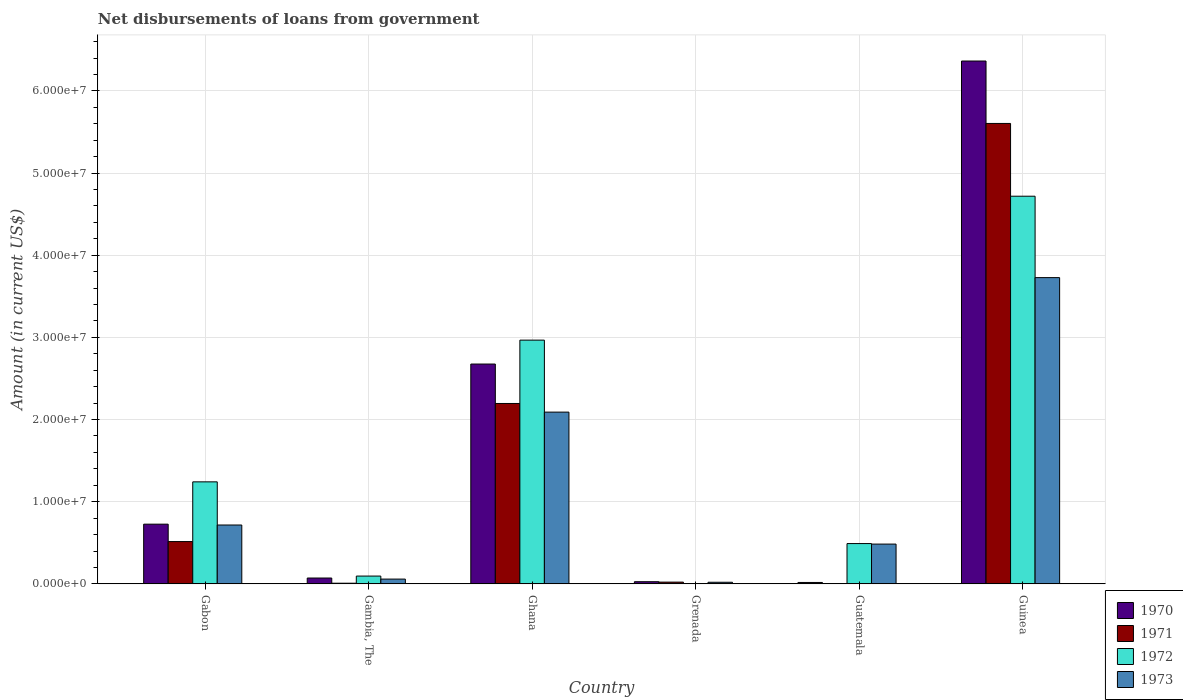Are the number of bars per tick equal to the number of legend labels?
Make the answer very short. No. How many bars are there on the 1st tick from the left?
Provide a succinct answer. 4. What is the label of the 5th group of bars from the left?
Offer a terse response. Guatemala. In how many cases, is the number of bars for a given country not equal to the number of legend labels?
Make the answer very short. 2. What is the amount of loan disbursed from government in 1970 in Ghana?
Give a very brief answer. 2.68e+07. Across all countries, what is the maximum amount of loan disbursed from government in 1970?
Your answer should be very brief. 6.36e+07. Across all countries, what is the minimum amount of loan disbursed from government in 1970?
Your response must be concise. 1.70e+05. In which country was the amount of loan disbursed from government in 1970 maximum?
Keep it short and to the point. Guinea. What is the total amount of loan disbursed from government in 1973 in the graph?
Keep it short and to the point. 7.10e+07. What is the difference between the amount of loan disbursed from government in 1973 in Gabon and that in Gambia, The?
Your answer should be compact. 6.58e+06. What is the difference between the amount of loan disbursed from government in 1971 in Gabon and the amount of loan disbursed from government in 1973 in Guatemala?
Keep it short and to the point. 3.07e+05. What is the average amount of loan disbursed from government in 1971 per country?
Offer a terse response. 1.39e+07. What is the difference between the amount of loan disbursed from government of/in 1972 and amount of loan disbursed from government of/in 1973 in Gabon?
Your answer should be compact. 5.25e+06. In how many countries, is the amount of loan disbursed from government in 1970 greater than 44000000 US$?
Your answer should be very brief. 1. What is the ratio of the amount of loan disbursed from government in 1973 in Gabon to that in Grenada?
Keep it short and to the point. 36.74. Is the amount of loan disbursed from government in 1971 in Gambia, The less than that in Grenada?
Give a very brief answer. Yes. Is the difference between the amount of loan disbursed from government in 1972 in Guatemala and Guinea greater than the difference between the amount of loan disbursed from government in 1973 in Guatemala and Guinea?
Give a very brief answer. No. What is the difference between the highest and the second highest amount of loan disbursed from government in 1970?
Keep it short and to the point. 3.69e+07. What is the difference between the highest and the lowest amount of loan disbursed from government in 1971?
Ensure brevity in your answer.  5.60e+07. In how many countries, is the amount of loan disbursed from government in 1973 greater than the average amount of loan disbursed from government in 1973 taken over all countries?
Provide a short and direct response. 2. Is the sum of the amount of loan disbursed from government in 1970 in Grenada and Guinea greater than the maximum amount of loan disbursed from government in 1972 across all countries?
Provide a succinct answer. Yes. Is it the case that in every country, the sum of the amount of loan disbursed from government in 1973 and amount of loan disbursed from government in 1972 is greater than the sum of amount of loan disbursed from government in 1971 and amount of loan disbursed from government in 1970?
Give a very brief answer. No. Is it the case that in every country, the sum of the amount of loan disbursed from government in 1973 and amount of loan disbursed from government in 1970 is greater than the amount of loan disbursed from government in 1972?
Provide a succinct answer. Yes. How many bars are there?
Your response must be concise. 22. Are all the bars in the graph horizontal?
Offer a terse response. No. Where does the legend appear in the graph?
Your answer should be very brief. Bottom right. How are the legend labels stacked?
Ensure brevity in your answer.  Vertical. What is the title of the graph?
Offer a terse response. Net disbursements of loans from government. What is the Amount (in current US$) of 1970 in Gabon?
Your answer should be compact. 7.27e+06. What is the Amount (in current US$) of 1971 in Gabon?
Your answer should be compact. 5.15e+06. What is the Amount (in current US$) in 1972 in Gabon?
Offer a very short reply. 1.24e+07. What is the Amount (in current US$) of 1973 in Gabon?
Ensure brevity in your answer.  7.16e+06. What is the Amount (in current US$) of 1970 in Gambia, The?
Offer a terse response. 7.11e+05. What is the Amount (in current US$) of 1971 in Gambia, The?
Offer a terse response. 8.00e+04. What is the Amount (in current US$) in 1972 in Gambia, The?
Give a very brief answer. 9.48e+05. What is the Amount (in current US$) of 1973 in Gambia, The?
Ensure brevity in your answer.  5.81e+05. What is the Amount (in current US$) of 1970 in Ghana?
Make the answer very short. 2.68e+07. What is the Amount (in current US$) in 1971 in Ghana?
Provide a short and direct response. 2.20e+07. What is the Amount (in current US$) in 1972 in Ghana?
Provide a succinct answer. 2.97e+07. What is the Amount (in current US$) in 1973 in Ghana?
Your answer should be very brief. 2.09e+07. What is the Amount (in current US$) of 1970 in Grenada?
Make the answer very short. 2.62e+05. What is the Amount (in current US$) in 1971 in Grenada?
Your response must be concise. 2.13e+05. What is the Amount (in current US$) in 1972 in Grenada?
Offer a terse response. 0. What is the Amount (in current US$) of 1973 in Grenada?
Your answer should be compact. 1.95e+05. What is the Amount (in current US$) of 1972 in Guatemala?
Offer a terse response. 4.90e+06. What is the Amount (in current US$) in 1973 in Guatemala?
Your answer should be compact. 4.84e+06. What is the Amount (in current US$) of 1970 in Guinea?
Your answer should be very brief. 6.36e+07. What is the Amount (in current US$) of 1971 in Guinea?
Give a very brief answer. 5.60e+07. What is the Amount (in current US$) in 1972 in Guinea?
Give a very brief answer. 4.72e+07. What is the Amount (in current US$) of 1973 in Guinea?
Your response must be concise. 3.73e+07. Across all countries, what is the maximum Amount (in current US$) in 1970?
Your answer should be compact. 6.36e+07. Across all countries, what is the maximum Amount (in current US$) in 1971?
Make the answer very short. 5.60e+07. Across all countries, what is the maximum Amount (in current US$) of 1972?
Your response must be concise. 4.72e+07. Across all countries, what is the maximum Amount (in current US$) in 1973?
Keep it short and to the point. 3.73e+07. Across all countries, what is the minimum Amount (in current US$) of 1971?
Make the answer very short. 0. Across all countries, what is the minimum Amount (in current US$) in 1972?
Keep it short and to the point. 0. Across all countries, what is the minimum Amount (in current US$) of 1973?
Keep it short and to the point. 1.95e+05. What is the total Amount (in current US$) in 1970 in the graph?
Ensure brevity in your answer.  9.88e+07. What is the total Amount (in current US$) in 1971 in the graph?
Provide a succinct answer. 8.34e+07. What is the total Amount (in current US$) of 1972 in the graph?
Keep it short and to the point. 9.51e+07. What is the total Amount (in current US$) in 1973 in the graph?
Your response must be concise. 7.10e+07. What is the difference between the Amount (in current US$) in 1970 in Gabon and that in Gambia, The?
Your answer should be compact. 6.56e+06. What is the difference between the Amount (in current US$) in 1971 in Gabon and that in Gambia, The?
Give a very brief answer. 5.07e+06. What is the difference between the Amount (in current US$) in 1972 in Gabon and that in Gambia, The?
Ensure brevity in your answer.  1.15e+07. What is the difference between the Amount (in current US$) in 1973 in Gabon and that in Gambia, The?
Offer a terse response. 6.58e+06. What is the difference between the Amount (in current US$) of 1970 in Gabon and that in Ghana?
Offer a very short reply. -1.95e+07. What is the difference between the Amount (in current US$) in 1971 in Gabon and that in Ghana?
Make the answer very short. -1.68e+07. What is the difference between the Amount (in current US$) in 1972 in Gabon and that in Ghana?
Give a very brief answer. -1.73e+07. What is the difference between the Amount (in current US$) in 1973 in Gabon and that in Ghana?
Offer a terse response. -1.37e+07. What is the difference between the Amount (in current US$) in 1970 in Gabon and that in Grenada?
Offer a very short reply. 7.01e+06. What is the difference between the Amount (in current US$) of 1971 in Gabon and that in Grenada?
Make the answer very short. 4.94e+06. What is the difference between the Amount (in current US$) of 1973 in Gabon and that in Grenada?
Provide a short and direct response. 6.97e+06. What is the difference between the Amount (in current US$) in 1970 in Gabon and that in Guatemala?
Give a very brief answer. 7.10e+06. What is the difference between the Amount (in current US$) of 1972 in Gabon and that in Guatemala?
Offer a very short reply. 7.51e+06. What is the difference between the Amount (in current US$) in 1973 in Gabon and that in Guatemala?
Your answer should be compact. 2.32e+06. What is the difference between the Amount (in current US$) in 1970 in Gabon and that in Guinea?
Offer a terse response. -5.64e+07. What is the difference between the Amount (in current US$) of 1971 in Gabon and that in Guinea?
Keep it short and to the point. -5.09e+07. What is the difference between the Amount (in current US$) of 1972 in Gabon and that in Guinea?
Give a very brief answer. -3.48e+07. What is the difference between the Amount (in current US$) in 1973 in Gabon and that in Guinea?
Your answer should be compact. -3.01e+07. What is the difference between the Amount (in current US$) in 1970 in Gambia, The and that in Ghana?
Ensure brevity in your answer.  -2.60e+07. What is the difference between the Amount (in current US$) of 1971 in Gambia, The and that in Ghana?
Your answer should be very brief. -2.19e+07. What is the difference between the Amount (in current US$) in 1972 in Gambia, The and that in Ghana?
Give a very brief answer. -2.87e+07. What is the difference between the Amount (in current US$) in 1973 in Gambia, The and that in Ghana?
Give a very brief answer. -2.03e+07. What is the difference between the Amount (in current US$) in 1970 in Gambia, The and that in Grenada?
Make the answer very short. 4.49e+05. What is the difference between the Amount (in current US$) in 1971 in Gambia, The and that in Grenada?
Provide a short and direct response. -1.33e+05. What is the difference between the Amount (in current US$) of 1973 in Gambia, The and that in Grenada?
Keep it short and to the point. 3.86e+05. What is the difference between the Amount (in current US$) in 1970 in Gambia, The and that in Guatemala?
Your answer should be compact. 5.41e+05. What is the difference between the Amount (in current US$) in 1972 in Gambia, The and that in Guatemala?
Provide a succinct answer. -3.96e+06. What is the difference between the Amount (in current US$) in 1973 in Gambia, The and that in Guatemala?
Your response must be concise. -4.26e+06. What is the difference between the Amount (in current US$) in 1970 in Gambia, The and that in Guinea?
Your answer should be compact. -6.29e+07. What is the difference between the Amount (in current US$) in 1971 in Gambia, The and that in Guinea?
Offer a terse response. -5.60e+07. What is the difference between the Amount (in current US$) of 1972 in Gambia, The and that in Guinea?
Provide a short and direct response. -4.62e+07. What is the difference between the Amount (in current US$) in 1973 in Gambia, The and that in Guinea?
Your response must be concise. -3.67e+07. What is the difference between the Amount (in current US$) in 1970 in Ghana and that in Grenada?
Offer a terse response. 2.65e+07. What is the difference between the Amount (in current US$) of 1971 in Ghana and that in Grenada?
Your answer should be compact. 2.17e+07. What is the difference between the Amount (in current US$) of 1973 in Ghana and that in Grenada?
Offer a very short reply. 2.07e+07. What is the difference between the Amount (in current US$) of 1970 in Ghana and that in Guatemala?
Provide a short and direct response. 2.66e+07. What is the difference between the Amount (in current US$) of 1972 in Ghana and that in Guatemala?
Offer a terse response. 2.48e+07. What is the difference between the Amount (in current US$) in 1973 in Ghana and that in Guatemala?
Offer a very short reply. 1.61e+07. What is the difference between the Amount (in current US$) of 1970 in Ghana and that in Guinea?
Provide a short and direct response. -3.69e+07. What is the difference between the Amount (in current US$) in 1971 in Ghana and that in Guinea?
Provide a short and direct response. -3.41e+07. What is the difference between the Amount (in current US$) of 1972 in Ghana and that in Guinea?
Keep it short and to the point. -1.75e+07. What is the difference between the Amount (in current US$) in 1973 in Ghana and that in Guinea?
Offer a very short reply. -1.64e+07. What is the difference between the Amount (in current US$) of 1970 in Grenada and that in Guatemala?
Give a very brief answer. 9.20e+04. What is the difference between the Amount (in current US$) in 1973 in Grenada and that in Guatemala?
Provide a succinct answer. -4.65e+06. What is the difference between the Amount (in current US$) of 1970 in Grenada and that in Guinea?
Keep it short and to the point. -6.34e+07. What is the difference between the Amount (in current US$) of 1971 in Grenada and that in Guinea?
Provide a short and direct response. -5.58e+07. What is the difference between the Amount (in current US$) of 1973 in Grenada and that in Guinea?
Ensure brevity in your answer.  -3.71e+07. What is the difference between the Amount (in current US$) in 1970 in Guatemala and that in Guinea?
Your answer should be compact. -6.35e+07. What is the difference between the Amount (in current US$) of 1972 in Guatemala and that in Guinea?
Ensure brevity in your answer.  -4.23e+07. What is the difference between the Amount (in current US$) of 1973 in Guatemala and that in Guinea?
Your answer should be compact. -3.24e+07. What is the difference between the Amount (in current US$) of 1970 in Gabon and the Amount (in current US$) of 1971 in Gambia, The?
Your answer should be very brief. 7.19e+06. What is the difference between the Amount (in current US$) in 1970 in Gabon and the Amount (in current US$) in 1972 in Gambia, The?
Offer a terse response. 6.32e+06. What is the difference between the Amount (in current US$) of 1970 in Gabon and the Amount (in current US$) of 1973 in Gambia, The?
Your answer should be very brief. 6.69e+06. What is the difference between the Amount (in current US$) in 1971 in Gabon and the Amount (in current US$) in 1972 in Gambia, The?
Make the answer very short. 4.20e+06. What is the difference between the Amount (in current US$) in 1971 in Gabon and the Amount (in current US$) in 1973 in Gambia, The?
Ensure brevity in your answer.  4.57e+06. What is the difference between the Amount (in current US$) of 1972 in Gabon and the Amount (in current US$) of 1973 in Gambia, The?
Your answer should be compact. 1.18e+07. What is the difference between the Amount (in current US$) in 1970 in Gabon and the Amount (in current US$) in 1971 in Ghana?
Your answer should be very brief. -1.47e+07. What is the difference between the Amount (in current US$) of 1970 in Gabon and the Amount (in current US$) of 1972 in Ghana?
Give a very brief answer. -2.24e+07. What is the difference between the Amount (in current US$) of 1970 in Gabon and the Amount (in current US$) of 1973 in Ghana?
Give a very brief answer. -1.36e+07. What is the difference between the Amount (in current US$) of 1971 in Gabon and the Amount (in current US$) of 1972 in Ghana?
Keep it short and to the point. -2.45e+07. What is the difference between the Amount (in current US$) in 1971 in Gabon and the Amount (in current US$) in 1973 in Ghana?
Give a very brief answer. -1.58e+07. What is the difference between the Amount (in current US$) in 1972 in Gabon and the Amount (in current US$) in 1973 in Ghana?
Your answer should be compact. -8.49e+06. What is the difference between the Amount (in current US$) of 1970 in Gabon and the Amount (in current US$) of 1971 in Grenada?
Ensure brevity in your answer.  7.06e+06. What is the difference between the Amount (in current US$) of 1970 in Gabon and the Amount (in current US$) of 1973 in Grenada?
Your answer should be very brief. 7.07e+06. What is the difference between the Amount (in current US$) of 1971 in Gabon and the Amount (in current US$) of 1973 in Grenada?
Your response must be concise. 4.95e+06. What is the difference between the Amount (in current US$) of 1972 in Gabon and the Amount (in current US$) of 1973 in Grenada?
Give a very brief answer. 1.22e+07. What is the difference between the Amount (in current US$) in 1970 in Gabon and the Amount (in current US$) in 1972 in Guatemala?
Provide a short and direct response. 2.36e+06. What is the difference between the Amount (in current US$) in 1970 in Gabon and the Amount (in current US$) in 1973 in Guatemala?
Give a very brief answer. 2.43e+06. What is the difference between the Amount (in current US$) in 1971 in Gabon and the Amount (in current US$) in 1972 in Guatemala?
Your answer should be very brief. 2.45e+05. What is the difference between the Amount (in current US$) in 1971 in Gabon and the Amount (in current US$) in 1973 in Guatemala?
Your answer should be very brief. 3.07e+05. What is the difference between the Amount (in current US$) in 1972 in Gabon and the Amount (in current US$) in 1973 in Guatemala?
Make the answer very short. 7.58e+06. What is the difference between the Amount (in current US$) of 1970 in Gabon and the Amount (in current US$) of 1971 in Guinea?
Provide a short and direct response. -4.88e+07. What is the difference between the Amount (in current US$) of 1970 in Gabon and the Amount (in current US$) of 1972 in Guinea?
Ensure brevity in your answer.  -3.99e+07. What is the difference between the Amount (in current US$) in 1970 in Gabon and the Amount (in current US$) in 1973 in Guinea?
Offer a terse response. -3.00e+07. What is the difference between the Amount (in current US$) in 1971 in Gabon and the Amount (in current US$) in 1972 in Guinea?
Ensure brevity in your answer.  -4.20e+07. What is the difference between the Amount (in current US$) in 1971 in Gabon and the Amount (in current US$) in 1973 in Guinea?
Make the answer very short. -3.21e+07. What is the difference between the Amount (in current US$) of 1972 in Gabon and the Amount (in current US$) of 1973 in Guinea?
Provide a succinct answer. -2.49e+07. What is the difference between the Amount (in current US$) of 1970 in Gambia, The and the Amount (in current US$) of 1971 in Ghana?
Make the answer very short. -2.12e+07. What is the difference between the Amount (in current US$) of 1970 in Gambia, The and the Amount (in current US$) of 1972 in Ghana?
Your response must be concise. -2.90e+07. What is the difference between the Amount (in current US$) of 1970 in Gambia, The and the Amount (in current US$) of 1973 in Ghana?
Your answer should be very brief. -2.02e+07. What is the difference between the Amount (in current US$) of 1971 in Gambia, The and the Amount (in current US$) of 1972 in Ghana?
Provide a short and direct response. -2.96e+07. What is the difference between the Amount (in current US$) of 1971 in Gambia, The and the Amount (in current US$) of 1973 in Ghana?
Provide a succinct answer. -2.08e+07. What is the difference between the Amount (in current US$) in 1972 in Gambia, The and the Amount (in current US$) in 1973 in Ghana?
Make the answer very short. -2.00e+07. What is the difference between the Amount (in current US$) in 1970 in Gambia, The and the Amount (in current US$) in 1971 in Grenada?
Your response must be concise. 4.98e+05. What is the difference between the Amount (in current US$) in 1970 in Gambia, The and the Amount (in current US$) in 1973 in Grenada?
Make the answer very short. 5.16e+05. What is the difference between the Amount (in current US$) of 1971 in Gambia, The and the Amount (in current US$) of 1973 in Grenada?
Your answer should be compact. -1.15e+05. What is the difference between the Amount (in current US$) of 1972 in Gambia, The and the Amount (in current US$) of 1973 in Grenada?
Give a very brief answer. 7.53e+05. What is the difference between the Amount (in current US$) of 1970 in Gambia, The and the Amount (in current US$) of 1972 in Guatemala?
Your answer should be very brief. -4.19e+06. What is the difference between the Amount (in current US$) in 1970 in Gambia, The and the Amount (in current US$) in 1973 in Guatemala?
Keep it short and to the point. -4.13e+06. What is the difference between the Amount (in current US$) of 1971 in Gambia, The and the Amount (in current US$) of 1972 in Guatemala?
Your answer should be very brief. -4.82e+06. What is the difference between the Amount (in current US$) of 1971 in Gambia, The and the Amount (in current US$) of 1973 in Guatemala?
Give a very brief answer. -4.76e+06. What is the difference between the Amount (in current US$) in 1972 in Gambia, The and the Amount (in current US$) in 1973 in Guatemala?
Offer a terse response. -3.89e+06. What is the difference between the Amount (in current US$) in 1970 in Gambia, The and the Amount (in current US$) in 1971 in Guinea?
Your answer should be very brief. -5.53e+07. What is the difference between the Amount (in current US$) of 1970 in Gambia, The and the Amount (in current US$) of 1972 in Guinea?
Your answer should be very brief. -4.65e+07. What is the difference between the Amount (in current US$) of 1970 in Gambia, The and the Amount (in current US$) of 1973 in Guinea?
Keep it short and to the point. -3.66e+07. What is the difference between the Amount (in current US$) in 1971 in Gambia, The and the Amount (in current US$) in 1972 in Guinea?
Make the answer very short. -4.71e+07. What is the difference between the Amount (in current US$) of 1971 in Gambia, The and the Amount (in current US$) of 1973 in Guinea?
Your answer should be compact. -3.72e+07. What is the difference between the Amount (in current US$) in 1972 in Gambia, The and the Amount (in current US$) in 1973 in Guinea?
Your response must be concise. -3.63e+07. What is the difference between the Amount (in current US$) in 1970 in Ghana and the Amount (in current US$) in 1971 in Grenada?
Keep it short and to the point. 2.65e+07. What is the difference between the Amount (in current US$) of 1970 in Ghana and the Amount (in current US$) of 1973 in Grenada?
Provide a succinct answer. 2.66e+07. What is the difference between the Amount (in current US$) in 1971 in Ghana and the Amount (in current US$) in 1973 in Grenada?
Keep it short and to the point. 2.18e+07. What is the difference between the Amount (in current US$) of 1972 in Ghana and the Amount (in current US$) of 1973 in Grenada?
Make the answer very short. 2.95e+07. What is the difference between the Amount (in current US$) in 1970 in Ghana and the Amount (in current US$) in 1972 in Guatemala?
Ensure brevity in your answer.  2.19e+07. What is the difference between the Amount (in current US$) of 1970 in Ghana and the Amount (in current US$) of 1973 in Guatemala?
Make the answer very short. 2.19e+07. What is the difference between the Amount (in current US$) of 1971 in Ghana and the Amount (in current US$) of 1972 in Guatemala?
Offer a terse response. 1.71e+07. What is the difference between the Amount (in current US$) in 1971 in Ghana and the Amount (in current US$) in 1973 in Guatemala?
Make the answer very short. 1.71e+07. What is the difference between the Amount (in current US$) in 1972 in Ghana and the Amount (in current US$) in 1973 in Guatemala?
Your answer should be compact. 2.48e+07. What is the difference between the Amount (in current US$) in 1970 in Ghana and the Amount (in current US$) in 1971 in Guinea?
Your answer should be compact. -2.93e+07. What is the difference between the Amount (in current US$) of 1970 in Ghana and the Amount (in current US$) of 1972 in Guinea?
Ensure brevity in your answer.  -2.04e+07. What is the difference between the Amount (in current US$) in 1970 in Ghana and the Amount (in current US$) in 1973 in Guinea?
Provide a succinct answer. -1.05e+07. What is the difference between the Amount (in current US$) in 1971 in Ghana and the Amount (in current US$) in 1972 in Guinea?
Provide a succinct answer. -2.52e+07. What is the difference between the Amount (in current US$) in 1971 in Ghana and the Amount (in current US$) in 1973 in Guinea?
Provide a succinct answer. -1.53e+07. What is the difference between the Amount (in current US$) in 1972 in Ghana and the Amount (in current US$) in 1973 in Guinea?
Your response must be concise. -7.61e+06. What is the difference between the Amount (in current US$) of 1970 in Grenada and the Amount (in current US$) of 1972 in Guatemala?
Offer a terse response. -4.64e+06. What is the difference between the Amount (in current US$) in 1970 in Grenada and the Amount (in current US$) in 1973 in Guatemala?
Provide a short and direct response. -4.58e+06. What is the difference between the Amount (in current US$) of 1971 in Grenada and the Amount (in current US$) of 1972 in Guatemala?
Provide a succinct answer. -4.69e+06. What is the difference between the Amount (in current US$) in 1971 in Grenada and the Amount (in current US$) in 1973 in Guatemala?
Provide a succinct answer. -4.63e+06. What is the difference between the Amount (in current US$) in 1970 in Grenada and the Amount (in current US$) in 1971 in Guinea?
Make the answer very short. -5.58e+07. What is the difference between the Amount (in current US$) of 1970 in Grenada and the Amount (in current US$) of 1972 in Guinea?
Provide a short and direct response. -4.69e+07. What is the difference between the Amount (in current US$) of 1970 in Grenada and the Amount (in current US$) of 1973 in Guinea?
Your answer should be compact. -3.70e+07. What is the difference between the Amount (in current US$) of 1971 in Grenada and the Amount (in current US$) of 1972 in Guinea?
Offer a terse response. -4.70e+07. What is the difference between the Amount (in current US$) of 1971 in Grenada and the Amount (in current US$) of 1973 in Guinea?
Make the answer very short. -3.71e+07. What is the difference between the Amount (in current US$) of 1970 in Guatemala and the Amount (in current US$) of 1971 in Guinea?
Make the answer very short. -5.59e+07. What is the difference between the Amount (in current US$) of 1970 in Guatemala and the Amount (in current US$) of 1972 in Guinea?
Provide a short and direct response. -4.70e+07. What is the difference between the Amount (in current US$) of 1970 in Guatemala and the Amount (in current US$) of 1973 in Guinea?
Offer a terse response. -3.71e+07. What is the difference between the Amount (in current US$) in 1972 in Guatemala and the Amount (in current US$) in 1973 in Guinea?
Offer a terse response. -3.24e+07. What is the average Amount (in current US$) in 1970 per country?
Your response must be concise. 1.65e+07. What is the average Amount (in current US$) in 1971 per country?
Your answer should be compact. 1.39e+07. What is the average Amount (in current US$) of 1972 per country?
Offer a terse response. 1.59e+07. What is the average Amount (in current US$) of 1973 per country?
Your answer should be compact. 1.18e+07. What is the difference between the Amount (in current US$) in 1970 and Amount (in current US$) in 1971 in Gabon?
Your answer should be compact. 2.12e+06. What is the difference between the Amount (in current US$) in 1970 and Amount (in current US$) in 1972 in Gabon?
Your answer should be compact. -5.15e+06. What is the difference between the Amount (in current US$) of 1970 and Amount (in current US$) of 1973 in Gabon?
Ensure brevity in your answer.  1.04e+05. What is the difference between the Amount (in current US$) of 1971 and Amount (in current US$) of 1972 in Gabon?
Your answer should be compact. -7.27e+06. What is the difference between the Amount (in current US$) in 1971 and Amount (in current US$) in 1973 in Gabon?
Give a very brief answer. -2.02e+06. What is the difference between the Amount (in current US$) in 1972 and Amount (in current US$) in 1973 in Gabon?
Your answer should be very brief. 5.25e+06. What is the difference between the Amount (in current US$) in 1970 and Amount (in current US$) in 1971 in Gambia, The?
Provide a short and direct response. 6.31e+05. What is the difference between the Amount (in current US$) in 1970 and Amount (in current US$) in 1972 in Gambia, The?
Keep it short and to the point. -2.37e+05. What is the difference between the Amount (in current US$) of 1971 and Amount (in current US$) of 1972 in Gambia, The?
Your answer should be compact. -8.68e+05. What is the difference between the Amount (in current US$) of 1971 and Amount (in current US$) of 1973 in Gambia, The?
Provide a succinct answer. -5.01e+05. What is the difference between the Amount (in current US$) in 1972 and Amount (in current US$) in 1973 in Gambia, The?
Ensure brevity in your answer.  3.67e+05. What is the difference between the Amount (in current US$) in 1970 and Amount (in current US$) in 1971 in Ghana?
Offer a very short reply. 4.80e+06. What is the difference between the Amount (in current US$) in 1970 and Amount (in current US$) in 1972 in Ghana?
Make the answer very short. -2.91e+06. What is the difference between the Amount (in current US$) in 1970 and Amount (in current US$) in 1973 in Ghana?
Your answer should be very brief. 5.85e+06. What is the difference between the Amount (in current US$) in 1971 and Amount (in current US$) in 1972 in Ghana?
Your answer should be very brief. -7.71e+06. What is the difference between the Amount (in current US$) of 1971 and Amount (in current US$) of 1973 in Ghana?
Offer a terse response. 1.05e+06. What is the difference between the Amount (in current US$) of 1972 and Amount (in current US$) of 1973 in Ghana?
Provide a short and direct response. 8.76e+06. What is the difference between the Amount (in current US$) in 1970 and Amount (in current US$) in 1971 in Grenada?
Your response must be concise. 4.90e+04. What is the difference between the Amount (in current US$) in 1970 and Amount (in current US$) in 1973 in Grenada?
Offer a very short reply. 6.70e+04. What is the difference between the Amount (in current US$) in 1971 and Amount (in current US$) in 1973 in Grenada?
Your response must be concise. 1.80e+04. What is the difference between the Amount (in current US$) of 1970 and Amount (in current US$) of 1972 in Guatemala?
Ensure brevity in your answer.  -4.73e+06. What is the difference between the Amount (in current US$) in 1970 and Amount (in current US$) in 1973 in Guatemala?
Keep it short and to the point. -4.67e+06. What is the difference between the Amount (in current US$) of 1972 and Amount (in current US$) of 1973 in Guatemala?
Make the answer very short. 6.20e+04. What is the difference between the Amount (in current US$) in 1970 and Amount (in current US$) in 1971 in Guinea?
Your response must be concise. 7.60e+06. What is the difference between the Amount (in current US$) in 1970 and Amount (in current US$) in 1972 in Guinea?
Your answer should be compact. 1.65e+07. What is the difference between the Amount (in current US$) of 1970 and Amount (in current US$) of 1973 in Guinea?
Offer a very short reply. 2.64e+07. What is the difference between the Amount (in current US$) in 1971 and Amount (in current US$) in 1972 in Guinea?
Ensure brevity in your answer.  8.86e+06. What is the difference between the Amount (in current US$) in 1971 and Amount (in current US$) in 1973 in Guinea?
Your answer should be compact. 1.88e+07. What is the difference between the Amount (in current US$) in 1972 and Amount (in current US$) in 1973 in Guinea?
Your answer should be very brief. 9.91e+06. What is the ratio of the Amount (in current US$) in 1970 in Gabon to that in Gambia, The?
Offer a terse response. 10.22. What is the ratio of the Amount (in current US$) of 1971 in Gabon to that in Gambia, The?
Offer a terse response. 64.36. What is the ratio of the Amount (in current US$) of 1972 in Gabon to that in Gambia, The?
Your answer should be compact. 13.1. What is the ratio of the Amount (in current US$) in 1973 in Gabon to that in Gambia, The?
Give a very brief answer. 12.33. What is the ratio of the Amount (in current US$) in 1970 in Gabon to that in Ghana?
Give a very brief answer. 0.27. What is the ratio of the Amount (in current US$) of 1971 in Gabon to that in Ghana?
Your answer should be very brief. 0.23. What is the ratio of the Amount (in current US$) in 1972 in Gabon to that in Ghana?
Provide a short and direct response. 0.42. What is the ratio of the Amount (in current US$) of 1973 in Gabon to that in Ghana?
Make the answer very short. 0.34. What is the ratio of the Amount (in current US$) in 1970 in Gabon to that in Grenada?
Your response must be concise. 27.74. What is the ratio of the Amount (in current US$) in 1971 in Gabon to that in Grenada?
Your answer should be compact. 24.17. What is the ratio of the Amount (in current US$) in 1973 in Gabon to that in Grenada?
Provide a short and direct response. 36.74. What is the ratio of the Amount (in current US$) in 1970 in Gabon to that in Guatemala?
Your answer should be compact. 42.75. What is the ratio of the Amount (in current US$) in 1972 in Gabon to that in Guatemala?
Keep it short and to the point. 2.53. What is the ratio of the Amount (in current US$) in 1973 in Gabon to that in Guatemala?
Ensure brevity in your answer.  1.48. What is the ratio of the Amount (in current US$) of 1970 in Gabon to that in Guinea?
Provide a short and direct response. 0.11. What is the ratio of the Amount (in current US$) in 1971 in Gabon to that in Guinea?
Provide a short and direct response. 0.09. What is the ratio of the Amount (in current US$) in 1972 in Gabon to that in Guinea?
Make the answer very short. 0.26. What is the ratio of the Amount (in current US$) of 1973 in Gabon to that in Guinea?
Keep it short and to the point. 0.19. What is the ratio of the Amount (in current US$) in 1970 in Gambia, The to that in Ghana?
Your answer should be very brief. 0.03. What is the ratio of the Amount (in current US$) in 1971 in Gambia, The to that in Ghana?
Your answer should be very brief. 0. What is the ratio of the Amount (in current US$) in 1972 in Gambia, The to that in Ghana?
Ensure brevity in your answer.  0.03. What is the ratio of the Amount (in current US$) of 1973 in Gambia, The to that in Ghana?
Your answer should be compact. 0.03. What is the ratio of the Amount (in current US$) of 1970 in Gambia, The to that in Grenada?
Your answer should be very brief. 2.71. What is the ratio of the Amount (in current US$) of 1971 in Gambia, The to that in Grenada?
Your answer should be very brief. 0.38. What is the ratio of the Amount (in current US$) in 1973 in Gambia, The to that in Grenada?
Keep it short and to the point. 2.98. What is the ratio of the Amount (in current US$) in 1970 in Gambia, The to that in Guatemala?
Your answer should be compact. 4.18. What is the ratio of the Amount (in current US$) of 1972 in Gambia, The to that in Guatemala?
Offer a terse response. 0.19. What is the ratio of the Amount (in current US$) of 1973 in Gambia, The to that in Guatemala?
Ensure brevity in your answer.  0.12. What is the ratio of the Amount (in current US$) of 1970 in Gambia, The to that in Guinea?
Your answer should be very brief. 0.01. What is the ratio of the Amount (in current US$) in 1971 in Gambia, The to that in Guinea?
Provide a short and direct response. 0. What is the ratio of the Amount (in current US$) in 1972 in Gambia, The to that in Guinea?
Provide a short and direct response. 0.02. What is the ratio of the Amount (in current US$) in 1973 in Gambia, The to that in Guinea?
Make the answer very short. 0.02. What is the ratio of the Amount (in current US$) of 1970 in Ghana to that in Grenada?
Provide a succinct answer. 102.13. What is the ratio of the Amount (in current US$) in 1971 in Ghana to that in Grenada?
Offer a very short reply. 103.09. What is the ratio of the Amount (in current US$) of 1973 in Ghana to that in Grenada?
Keep it short and to the point. 107.22. What is the ratio of the Amount (in current US$) of 1970 in Ghana to that in Guatemala?
Provide a succinct answer. 157.41. What is the ratio of the Amount (in current US$) in 1972 in Ghana to that in Guatemala?
Your response must be concise. 6.05. What is the ratio of the Amount (in current US$) of 1973 in Ghana to that in Guatemala?
Ensure brevity in your answer.  4.32. What is the ratio of the Amount (in current US$) in 1970 in Ghana to that in Guinea?
Your answer should be compact. 0.42. What is the ratio of the Amount (in current US$) in 1971 in Ghana to that in Guinea?
Your answer should be very brief. 0.39. What is the ratio of the Amount (in current US$) in 1972 in Ghana to that in Guinea?
Your answer should be very brief. 0.63. What is the ratio of the Amount (in current US$) of 1973 in Ghana to that in Guinea?
Make the answer very short. 0.56. What is the ratio of the Amount (in current US$) of 1970 in Grenada to that in Guatemala?
Your answer should be compact. 1.54. What is the ratio of the Amount (in current US$) in 1973 in Grenada to that in Guatemala?
Ensure brevity in your answer.  0.04. What is the ratio of the Amount (in current US$) of 1970 in Grenada to that in Guinea?
Your answer should be very brief. 0. What is the ratio of the Amount (in current US$) of 1971 in Grenada to that in Guinea?
Make the answer very short. 0. What is the ratio of the Amount (in current US$) of 1973 in Grenada to that in Guinea?
Provide a succinct answer. 0.01. What is the ratio of the Amount (in current US$) in 1970 in Guatemala to that in Guinea?
Provide a succinct answer. 0. What is the ratio of the Amount (in current US$) of 1972 in Guatemala to that in Guinea?
Offer a very short reply. 0.1. What is the ratio of the Amount (in current US$) in 1973 in Guatemala to that in Guinea?
Provide a short and direct response. 0.13. What is the difference between the highest and the second highest Amount (in current US$) of 1970?
Provide a succinct answer. 3.69e+07. What is the difference between the highest and the second highest Amount (in current US$) in 1971?
Provide a short and direct response. 3.41e+07. What is the difference between the highest and the second highest Amount (in current US$) of 1972?
Your answer should be compact. 1.75e+07. What is the difference between the highest and the second highest Amount (in current US$) in 1973?
Your answer should be compact. 1.64e+07. What is the difference between the highest and the lowest Amount (in current US$) of 1970?
Give a very brief answer. 6.35e+07. What is the difference between the highest and the lowest Amount (in current US$) of 1971?
Your answer should be very brief. 5.60e+07. What is the difference between the highest and the lowest Amount (in current US$) in 1972?
Offer a very short reply. 4.72e+07. What is the difference between the highest and the lowest Amount (in current US$) of 1973?
Provide a succinct answer. 3.71e+07. 